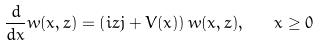<formula> <loc_0><loc_0><loc_500><loc_500>\frac { d } { d x } w ( x , z ) = \left ( i z j + V ( x ) \right ) w ( x , z ) , \quad x \geq 0</formula> 